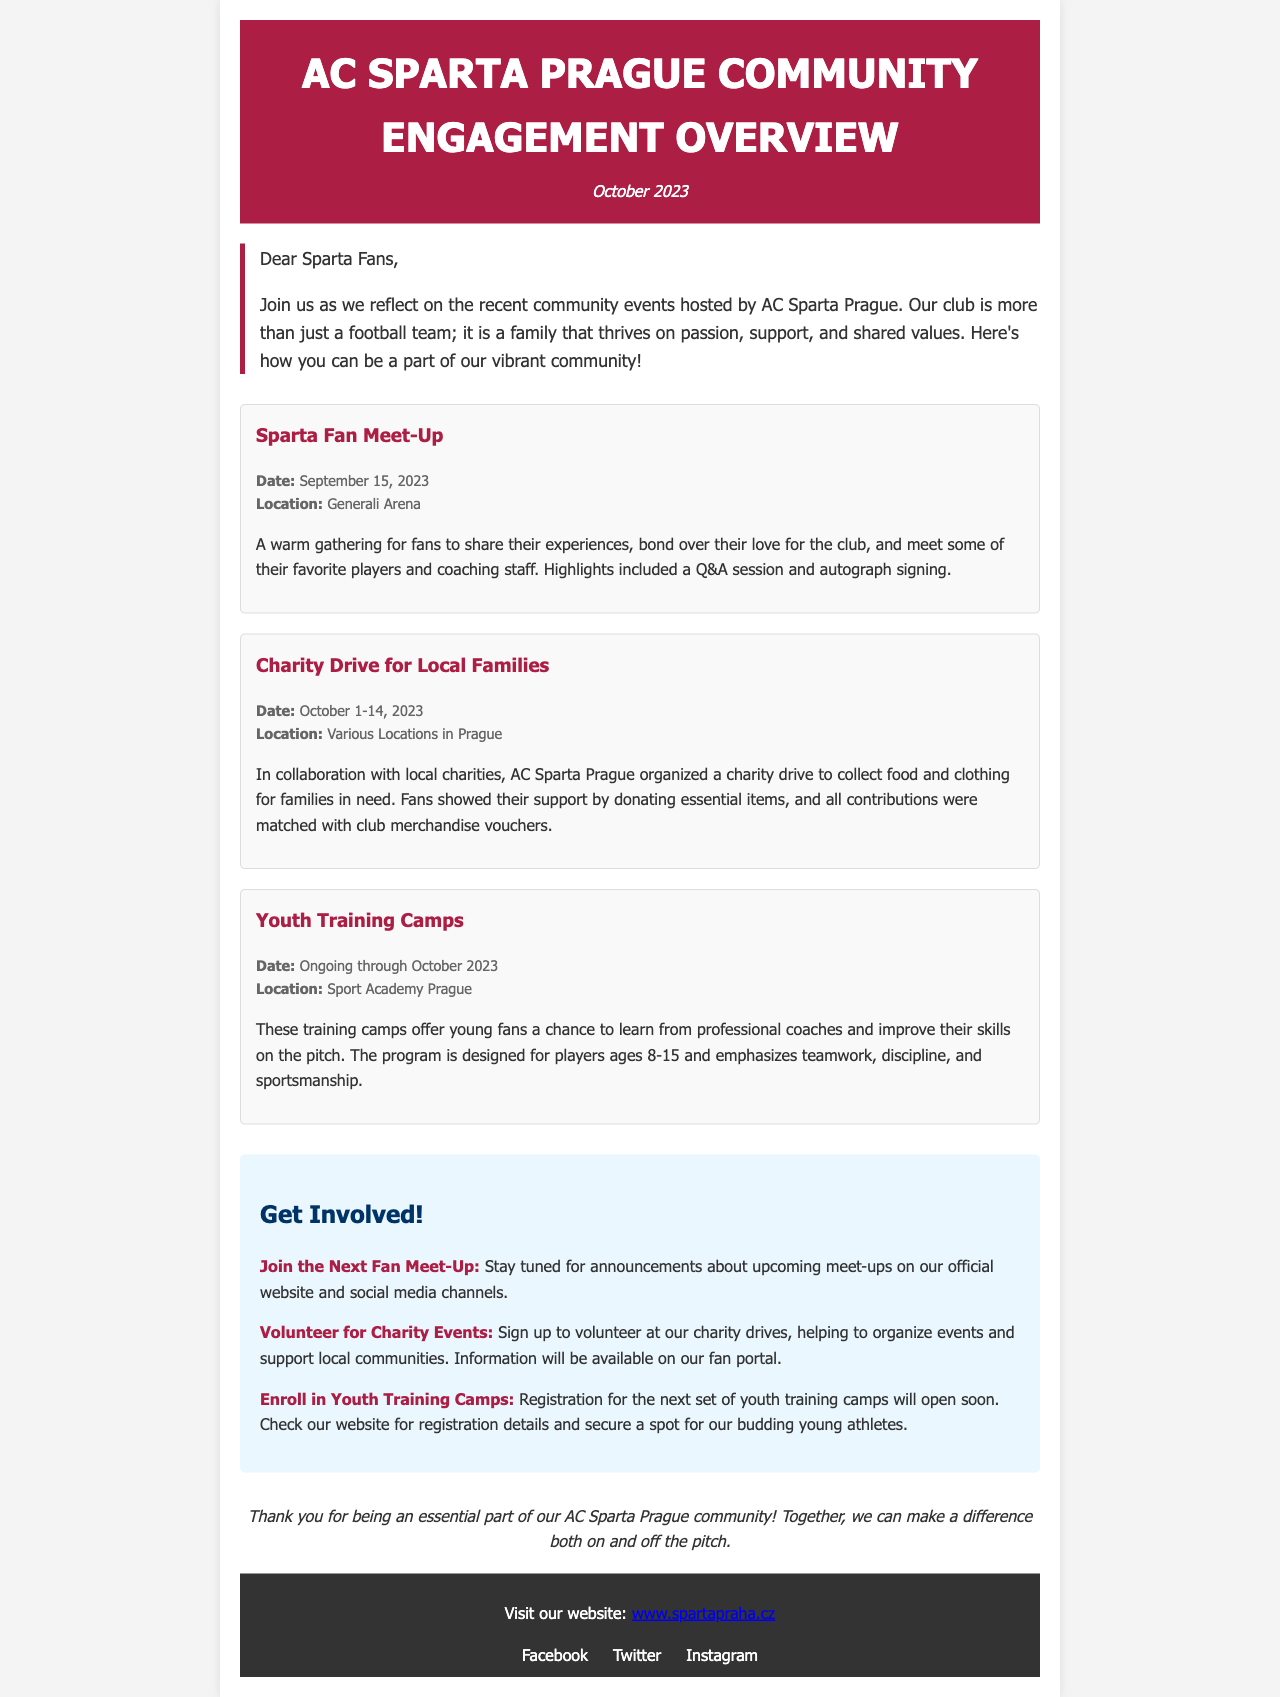What was the date of the Sparta Fan Meet-Up? The document provides the specific date for the event which is September 15, 2023.
Answer: September 15, 2023 Where was the Charity Drive for Local Families held? The document states that the charity drive took place at various locations in Prague.
Answer: Various Locations in Prague What is the age range for participants in the Youth Training Camps? The document mentions that the training camps are designed for players ages 8-15.
Answer: 8-15 What is the main purpose of the Charity Drive? The document describes the charity drive's purpose as collecting food and clothing for families in need.
Answer: Collect food and clothing for families in need What can fans do to get involved in charity events? The document explains that fans can volunteer at charity drives to help organize events and support local communities.
Answer: Volunteer at charity drives How will fans be informed about the next Fan Meet-Up? The document indicates that announcements will be made on the official website and social media channels.
Answer: Official website and social media channels What should fans do to enroll in the Youth Training Camps? The document states that fans should check the website for registration details.
Answer: Check the website for registration details Which club is mentioned in the newsletter? The document is focused on community engagement related to AC Sparta Prague.
Answer: AC Sparta Prague What colors are used for the header background? The document specifies that the header background color is a shade of red, identified by the hex code #AC1E44.
Answer: #AC1E44 